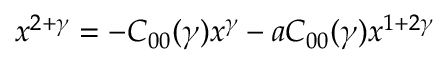<formula> <loc_0><loc_0><loc_500><loc_500>x ^ { 2 + \gamma } = - C _ { 0 0 } ( \gamma ) x ^ { \gamma } - a C _ { 0 0 } ( \gamma ) x ^ { 1 + 2 \gamma }</formula> 